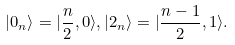Convert formula to latex. <formula><loc_0><loc_0><loc_500><loc_500>| 0 _ { n } \rangle = | \frac { n } { 2 } , 0 \rangle , | 2 _ { n } \rangle = | \frac { n - 1 } { 2 } , 1 \rangle .</formula> 